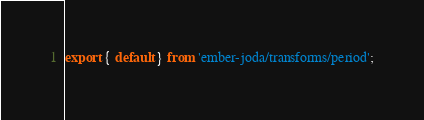<code> <loc_0><loc_0><loc_500><loc_500><_JavaScript_>export { default } from 'ember-joda/transforms/period';
</code> 